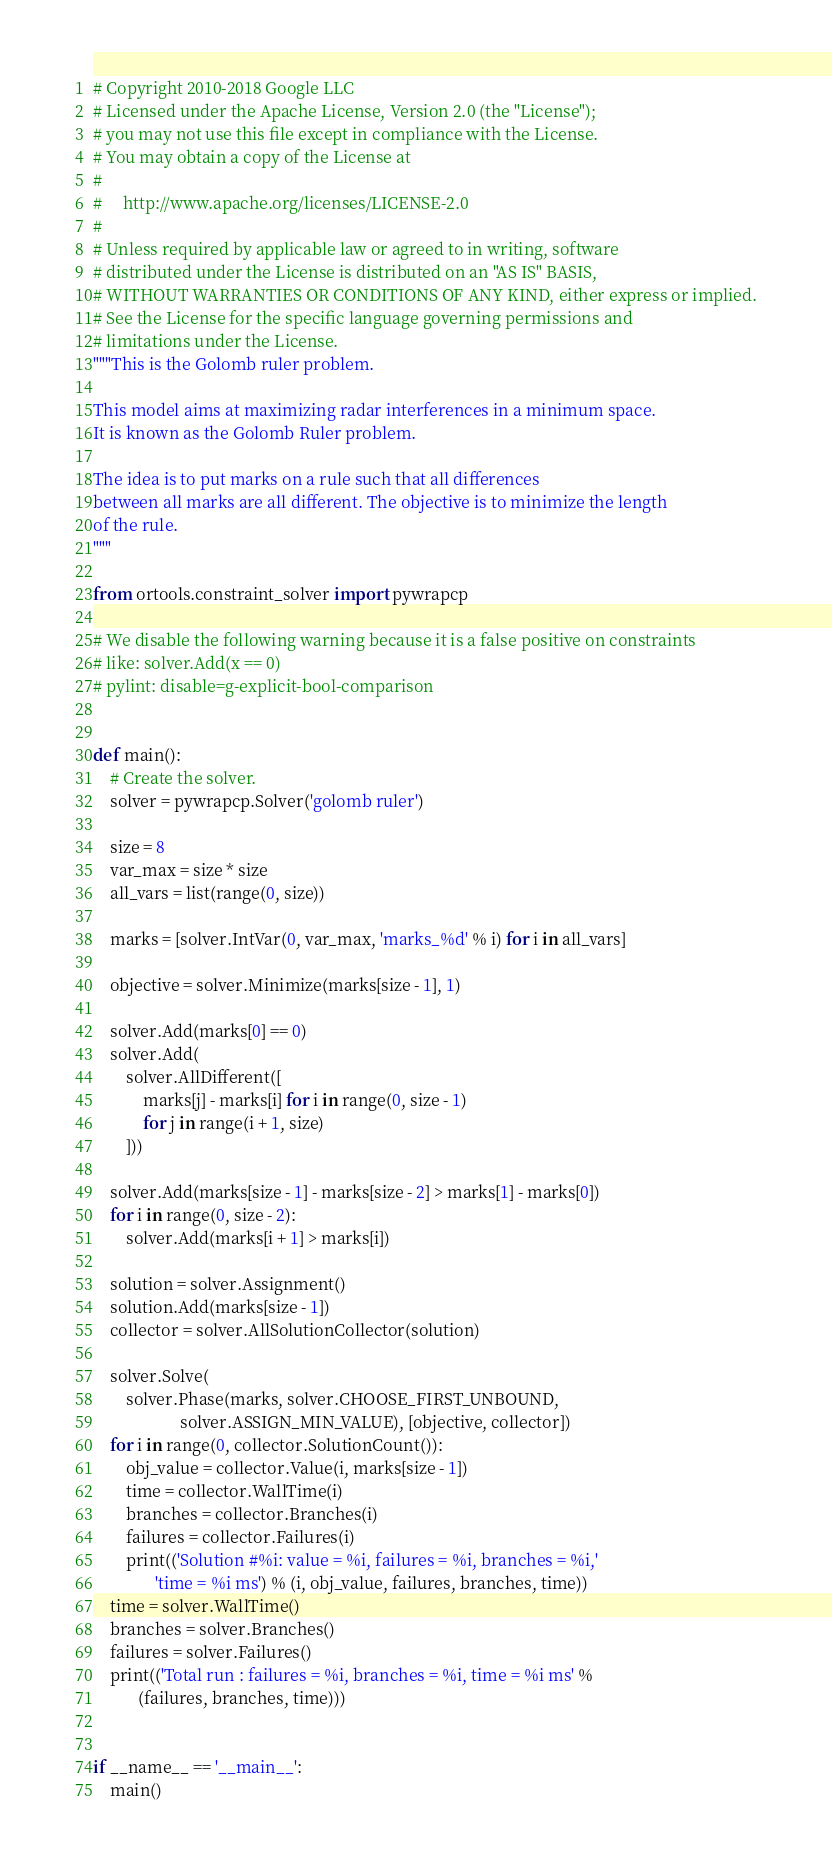<code> <loc_0><loc_0><loc_500><loc_500><_Python_># Copyright 2010-2018 Google LLC
# Licensed under the Apache License, Version 2.0 (the "License");
# you may not use this file except in compliance with the License.
# You may obtain a copy of the License at
#
#     http://www.apache.org/licenses/LICENSE-2.0
#
# Unless required by applicable law or agreed to in writing, software
# distributed under the License is distributed on an "AS IS" BASIS,
# WITHOUT WARRANTIES OR CONDITIONS OF ANY KIND, either express or implied.
# See the License for the specific language governing permissions and
# limitations under the License.
"""This is the Golomb ruler problem.

This model aims at maximizing radar interferences in a minimum space.
It is known as the Golomb Ruler problem.

The idea is to put marks on a rule such that all differences
between all marks are all different. The objective is to minimize the length
of the rule.
"""

from ortools.constraint_solver import pywrapcp

# We disable the following warning because it is a false positive on constraints
# like: solver.Add(x == 0)
# pylint: disable=g-explicit-bool-comparison


def main():
    # Create the solver.
    solver = pywrapcp.Solver('golomb ruler')

    size = 8
    var_max = size * size
    all_vars = list(range(0, size))

    marks = [solver.IntVar(0, var_max, 'marks_%d' % i) for i in all_vars]

    objective = solver.Minimize(marks[size - 1], 1)

    solver.Add(marks[0] == 0)
    solver.Add(
        solver.AllDifferent([
            marks[j] - marks[i] for i in range(0, size - 1)
            for j in range(i + 1, size)
        ]))

    solver.Add(marks[size - 1] - marks[size - 2] > marks[1] - marks[0])
    for i in range(0, size - 2):
        solver.Add(marks[i + 1] > marks[i])

    solution = solver.Assignment()
    solution.Add(marks[size - 1])
    collector = solver.AllSolutionCollector(solution)

    solver.Solve(
        solver.Phase(marks, solver.CHOOSE_FIRST_UNBOUND,
                     solver.ASSIGN_MIN_VALUE), [objective, collector])
    for i in range(0, collector.SolutionCount()):
        obj_value = collector.Value(i, marks[size - 1])
        time = collector.WallTime(i)
        branches = collector.Branches(i)
        failures = collector.Failures(i)
        print(('Solution #%i: value = %i, failures = %i, branches = %i,'
               'time = %i ms') % (i, obj_value, failures, branches, time))
    time = solver.WallTime()
    branches = solver.Branches()
    failures = solver.Failures()
    print(('Total run : failures = %i, branches = %i, time = %i ms' %
           (failures, branches, time)))


if __name__ == '__main__':
    main()
</code> 